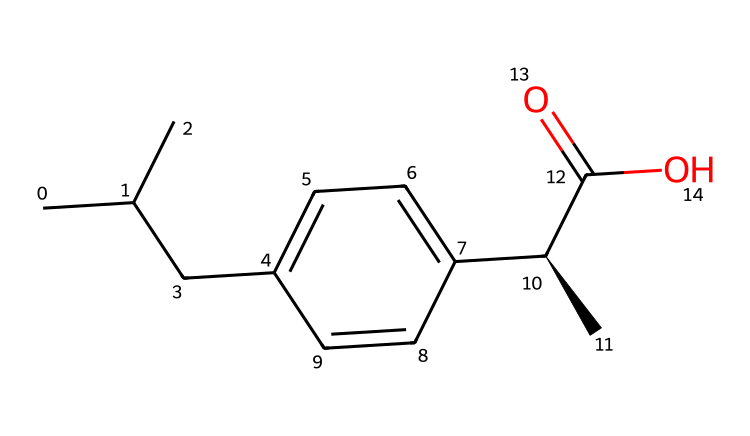What is the molecular formula of ibuprofen? By analyzing the provided SMILES representation, we can count the numbers of each type of atom. The breakdown is as follows: there are 13 carbon (C) atoms, 18 hydrogen (H) atoms, and 2 oxygen (O) atoms. Therefore, the molecular formula is C13H18O2.
Answer: C13H18O2 How many rings are present in the ibuprofen structure? Upon examining the SMILES, there are no occurrences of ring structures indicated. This structure consists of a straight-chain carbon backbone with various functional groups but no rings.
Answer: 0 What type of functional group is present in ibuprofen? The SMILES indicates a carboxylic acid functional group (C(=O)O) towards the end of the structure. This characteristic group is integral to the chemical properties of ibuprofen.
Answer: carboxylic acid How many chiral centers are in ibuprofen? In the SMILES representation, there is one chiral center, specifically the carbon denoted with [C@H]. This indicates that the compound has the potential for stereochemistry, which is significant for its biological activity.
Answer: 1 What is the significance of the molecular composition of ibuprofen for its pharmacological action? Ibuprofen's structure, particularly the presence of the carboxylic acid and its specific stereochemistry, influences how it interacts with cyclooxygenase enzymes, thereby affecting its anti-inflammatory and analgesic properties.
Answer: pharmacological action 